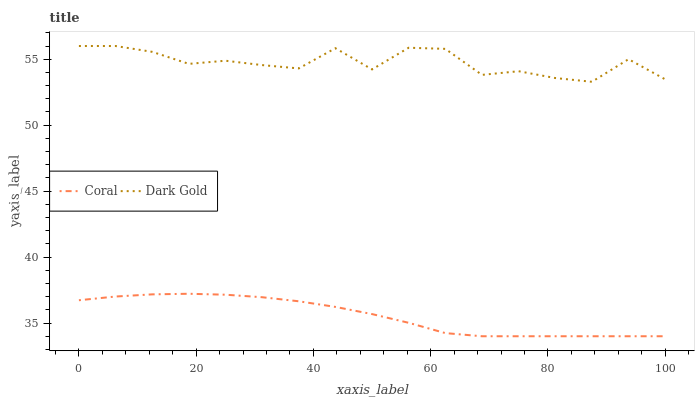Does Coral have the minimum area under the curve?
Answer yes or no. Yes. Does Dark Gold have the maximum area under the curve?
Answer yes or no. Yes. Does Dark Gold have the minimum area under the curve?
Answer yes or no. No. Is Coral the smoothest?
Answer yes or no. Yes. Is Dark Gold the roughest?
Answer yes or no. Yes. Is Dark Gold the smoothest?
Answer yes or no. No. Does Coral have the lowest value?
Answer yes or no. Yes. Does Dark Gold have the lowest value?
Answer yes or no. No. Does Dark Gold have the highest value?
Answer yes or no. Yes. Is Coral less than Dark Gold?
Answer yes or no. Yes. Is Dark Gold greater than Coral?
Answer yes or no. Yes. Does Coral intersect Dark Gold?
Answer yes or no. No. 